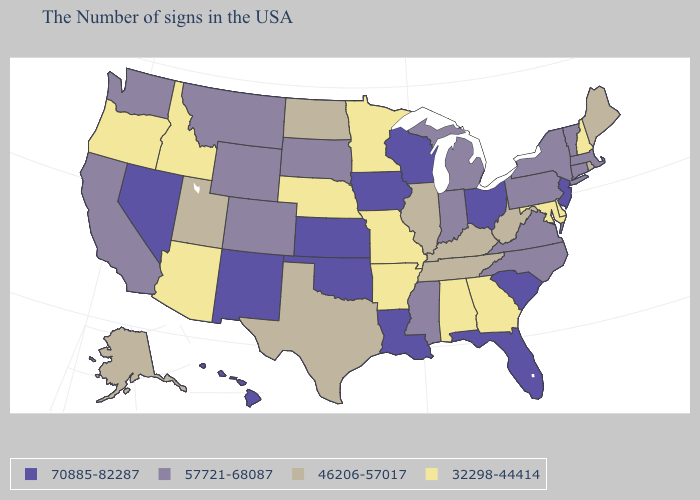What is the lowest value in the South?
Quick response, please. 32298-44414. Which states have the lowest value in the Northeast?
Short answer required. New Hampshire. Name the states that have a value in the range 70885-82287?
Quick response, please. New Jersey, South Carolina, Ohio, Florida, Wisconsin, Louisiana, Iowa, Kansas, Oklahoma, New Mexico, Nevada, Hawaii. Which states have the lowest value in the USA?
Quick response, please. New Hampshire, Delaware, Maryland, Georgia, Alabama, Missouri, Arkansas, Minnesota, Nebraska, Arizona, Idaho, Oregon. What is the value of Delaware?
Quick response, please. 32298-44414. Among the states that border Montana , which have the lowest value?
Be succinct. Idaho. How many symbols are there in the legend?
Short answer required. 4. Does the first symbol in the legend represent the smallest category?
Write a very short answer. No. Name the states that have a value in the range 46206-57017?
Answer briefly. Maine, Rhode Island, West Virginia, Kentucky, Tennessee, Illinois, Texas, North Dakota, Utah, Alaska. What is the value of South Carolina?
Concise answer only. 70885-82287. Does the map have missing data?
Write a very short answer. No. Is the legend a continuous bar?
Answer briefly. No. Which states have the highest value in the USA?
Be succinct. New Jersey, South Carolina, Ohio, Florida, Wisconsin, Louisiana, Iowa, Kansas, Oklahoma, New Mexico, Nevada, Hawaii. What is the value of Pennsylvania?
Keep it brief. 57721-68087. Does Oklahoma have the lowest value in the USA?
Write a very short answer. No. 